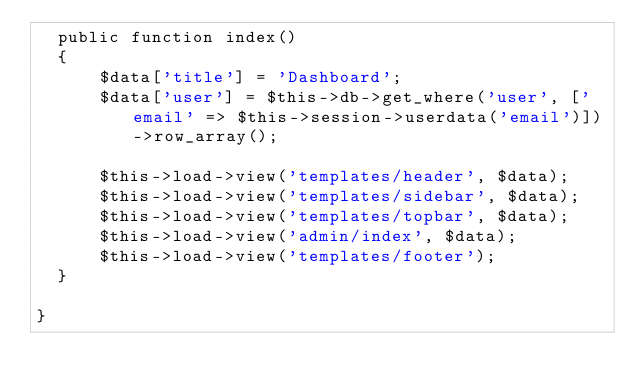Convert code to text. <code><loc_0><loc_0><loc_500><loc_500><_PHP_>  public function index()
  {
      $data['title'] = 'Dashboard';
      $data['user'] = $this->db->get_where('user', ['email' => $this->session->userdata('email')])->row_array();
     
      $this->load->view('templates/header', $data);
      $this->load->view('templates/sidebar', $data);
      $this->load->view('templates/topbar', $data);
      $this->load->view('admin/index', $data);
      $this->load->view('templates/footer');
  }

}
</code> 